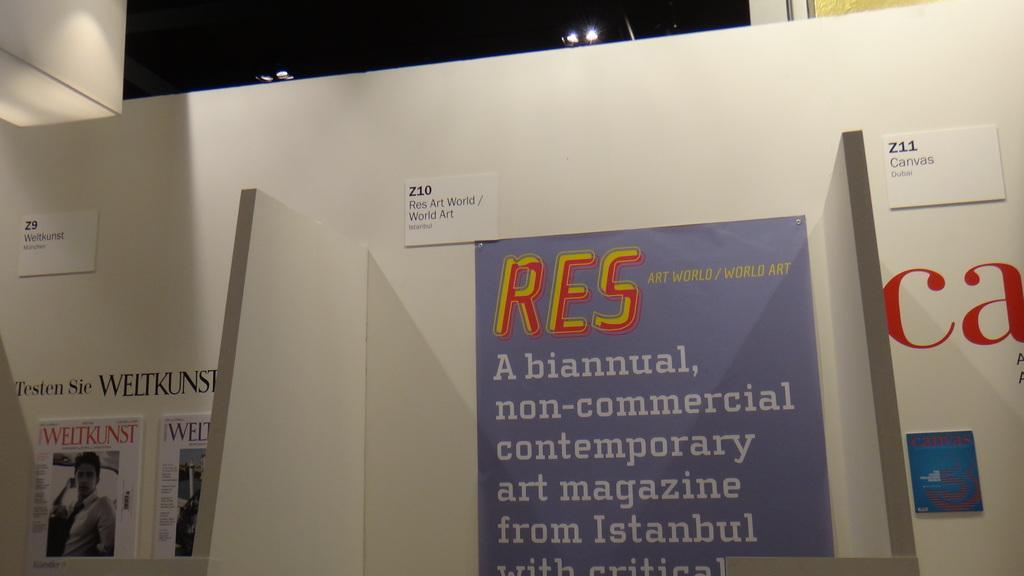Can you describe this image briefly? In this picture there is a paper which has something written on it is attached to a white color object behind it. 